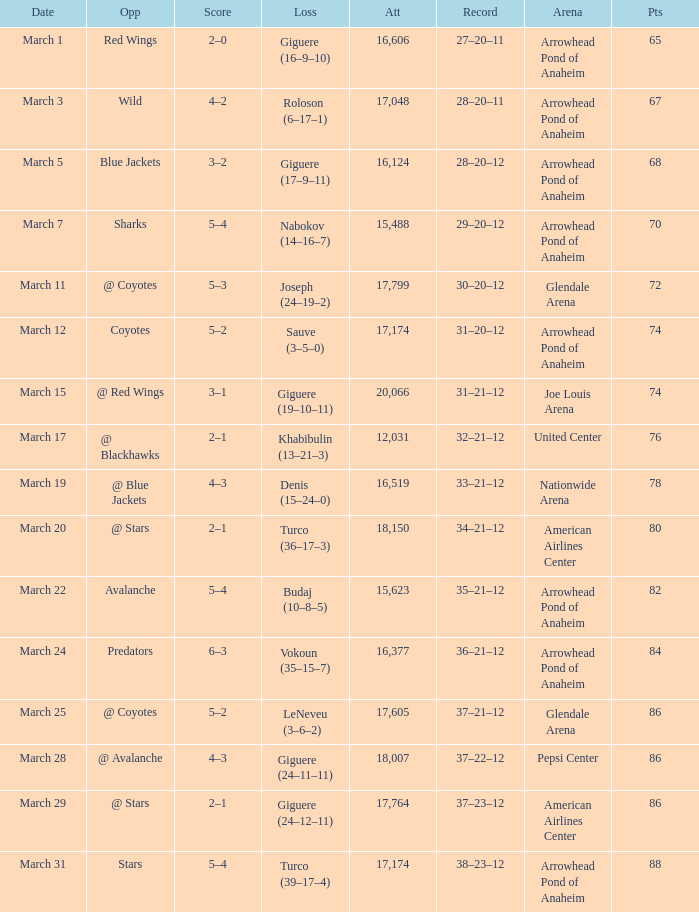What is the Loss of the game at Nationwide Arena with a Score of 4–3? Denis (15–24–0). 